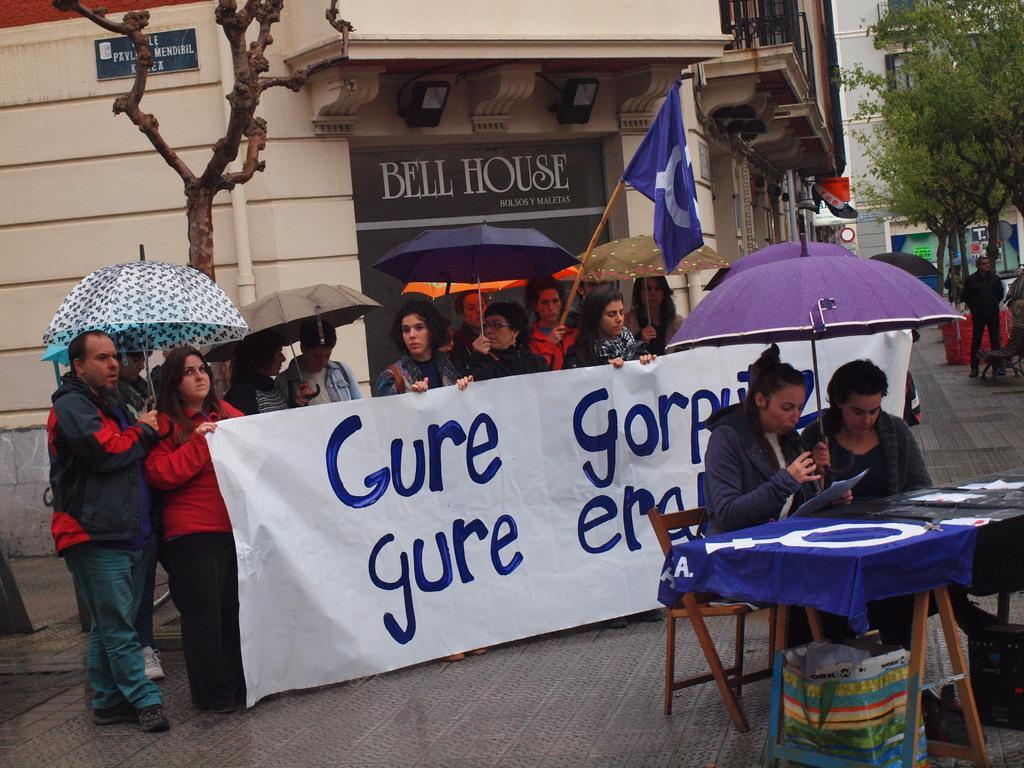Please provide a concise description of this image. This picture is clicked outside the city. In the middle of the picture, we see people standing on the road and they are holding umbrellas in their hands. We even see people are holding a white banner with some text written on it. The woman in the red jacket is holding a blue color flag in her hand. In the right bottom of the picture, we see two women are sitting on the chairs. They are holding an umbrella and papers in their hands. In front of them, we see a table which is covered with blue color cloth. Under the table, we see a plastic bag. On the right side, we see men are standing. There are buildings and trees in the background. 